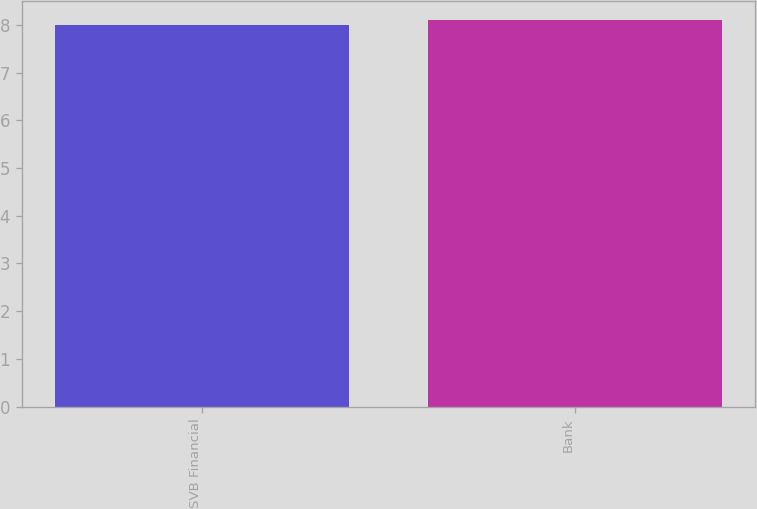Convert chart. <chart><loc_0><loc_0><loc_500><loc_500><bar_chart><fcel>SVB Financial<fcel>Bank<nl><fcel>8<fcel>8.1<nl></chart> 